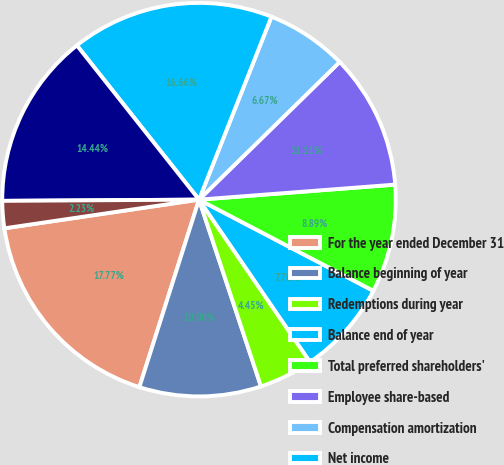Convert chart to OTSL. <chart><loc_0><loc_0><loc_500><loc_500><pie_chart><fcel>For the year ended December 31<fcel>Balance beginning of year<fcel>Redemptions during year<fcel>Balance end of year<fcel>Total preferred shareholders'<fcel>Employee share-based<fcel>Compensation amortization<fcel>Net income<fcel>Dividends<fcel>Minority interest and other<nl><fcel>17.77%<fcel>10.0%<fcel>4.45%<fcel>7.78%<fcel>8.89%<fcel>11.11%<fcel>6.67%<fcel>16.66%<fcel>14.44%<fcel>2.23%<nl></chart> 